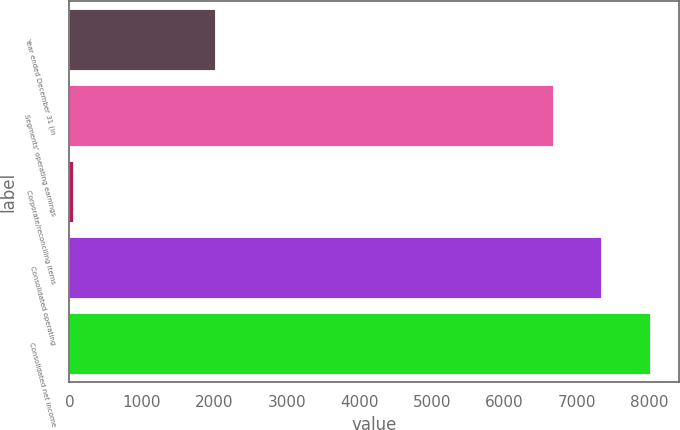Convert chart. <chart><loc_0><loc_0><loc_500><loc_500><bar_chart><fcel>Year ended December 31 (in<fcel>Segments' operating earnings<fcel>Corporate/reconciling items<fcel>Consolidated operating<fcel>Consolidated net income<nl><fcel>2003<fcel>6675<fcel>44<fcel>7342.5<fcel>8010<nl></chart> 